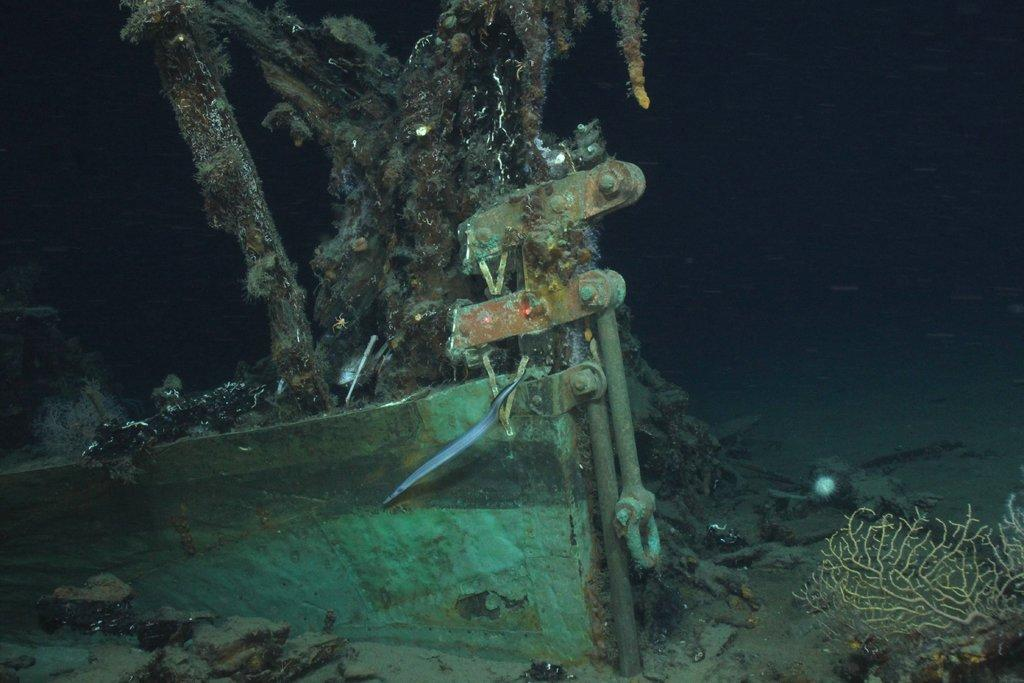What is the main subject of the image? The main subject of the image is a ship. Where is the ship located? The ship is inside a water body. What else can be seen in the water body? There is a coral reef in the image. What is the tendency of the dime to float in the water body in the image? There is no dime present in the image, so it's not possible to determine its tendency to float in the water body. How many snails can be seen on the coral reef in the image? There are no snails visible on the coral reef in the image. 